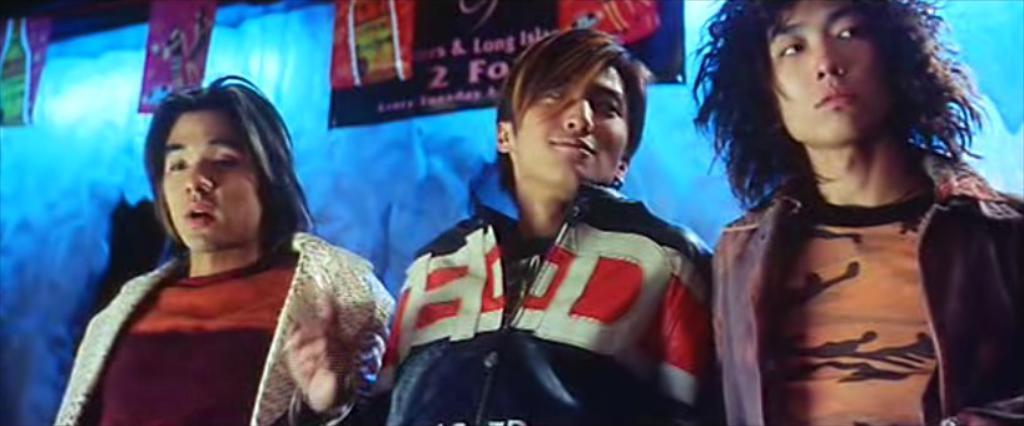How many people are in the image? There are three people in the image. What are the people doing in the image? The people are standing and smiling. What can be seen in the background of the image? There are boards in the background of the image. What type of plantation can be seen in the image? There is no plantation present in the image. How does the lead affect the digestion of the people in the image? There is no mention of lead or digestion in the image, so it cannot be determined how lead might affect the people's digestion. 